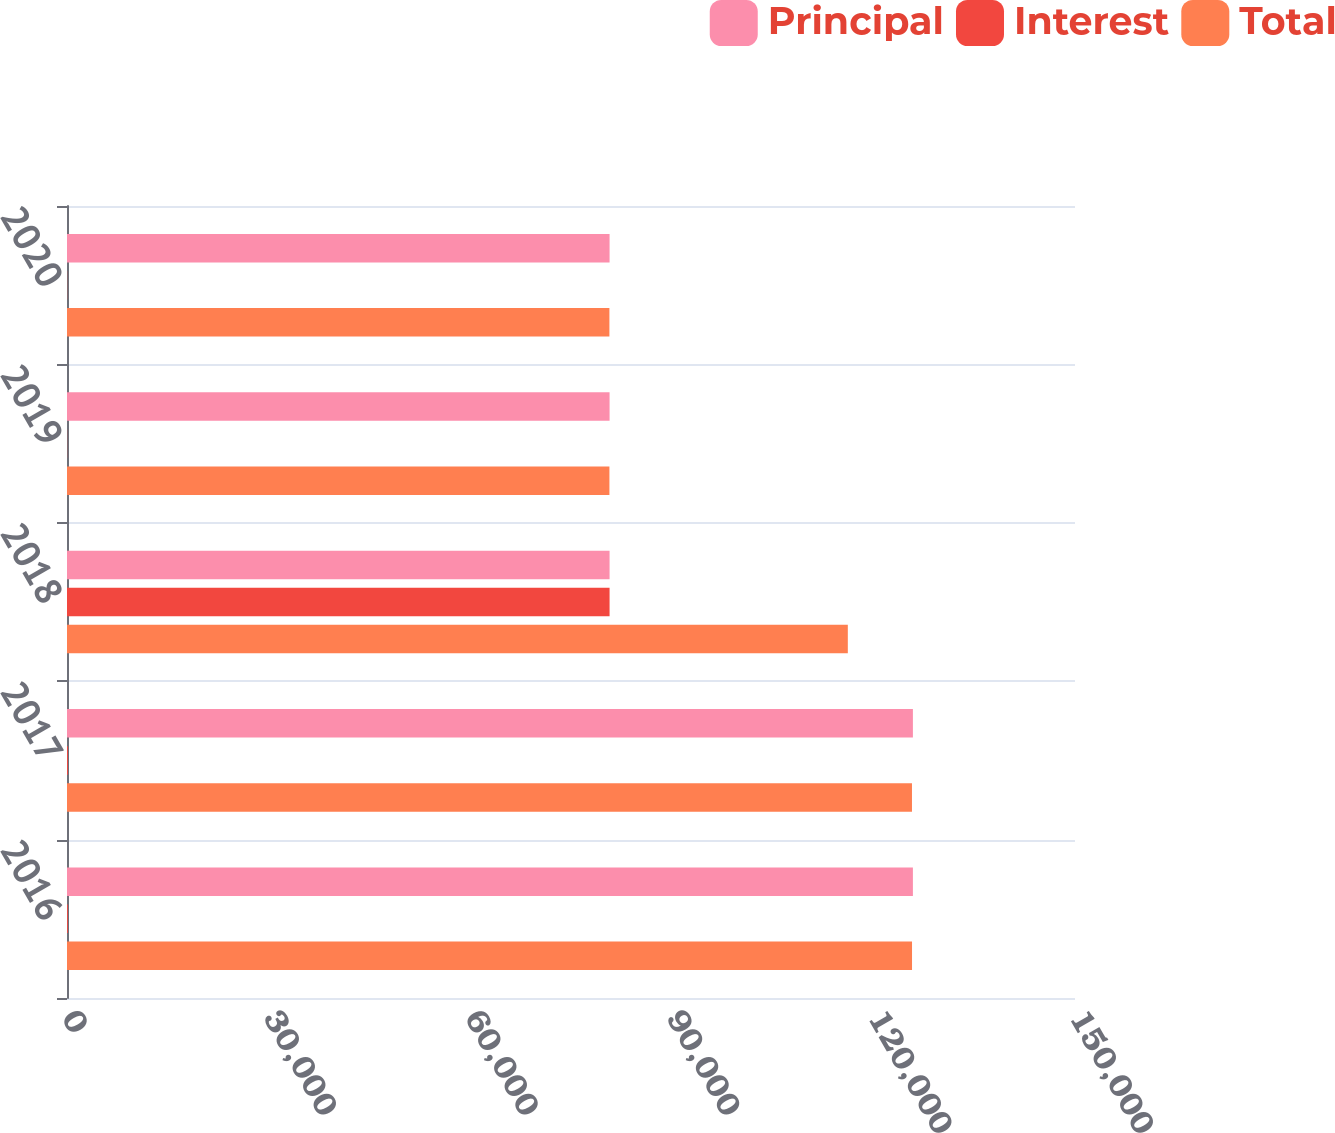<chart> <loc_0><loc_0><loc_500><loc_500><stacked_bar_chart><ecel><fcel>2016<fcel>2017<fcel>2018<fcel>2019<fcel>2020<nl><fcel>Principal<fcel>125878<fcel>125878<fcel>80740<fcel>80740<fcel>80740<nl><fcel>Interest<fcel>130<fcel>138<fcel>80740<fcel>23<fcel>25<nl><fcel>Total<fcel>125748<fcel>125740<fcel>116194<fcel>80717<fcel>80715<nl></chart> 